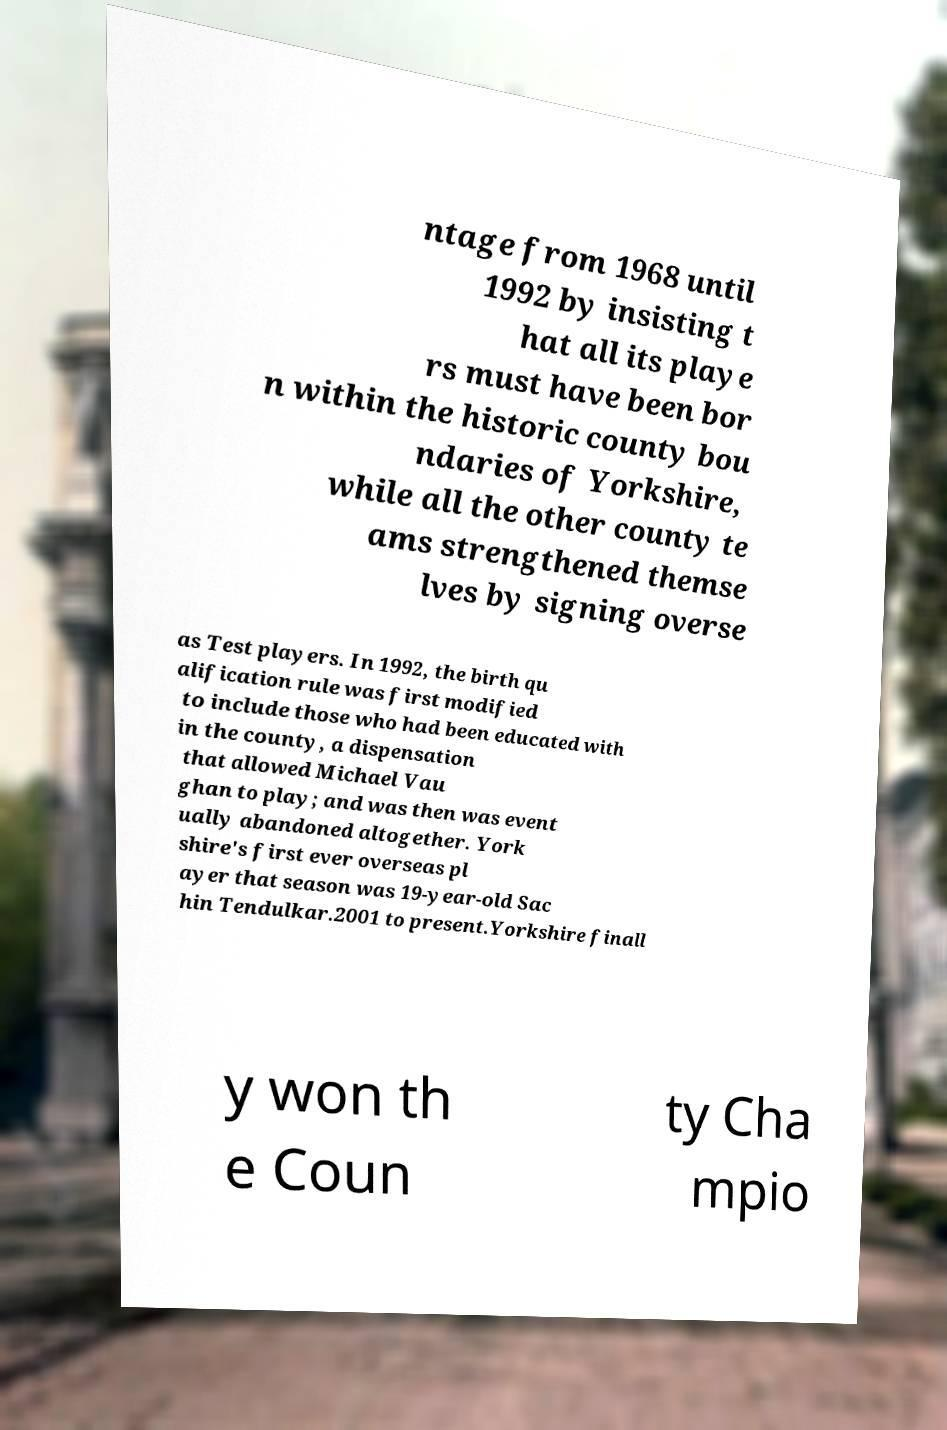What messages or text are displayed in this image? I need them in a readable, typed format. ntage from 1968 until 1992 by insisting t hat all its playe rs must have been bor n within the historic county bou ndaries of Yorkshire, while all the other county te ams strengthened themse lves by signing overse as Test players. In 1992, the birth qu alification rule was first modified to include those who had been educated with in the county, a dispensation that allowed Michael Vau ghan to play; and was then was event ually abandoned altogether. York shire's first ever overseas pl ayer that season was 19-year-old Sac hin Tendulkar.2001 to present.Yorkshire finall y won th e Coun ty Cha mpio 